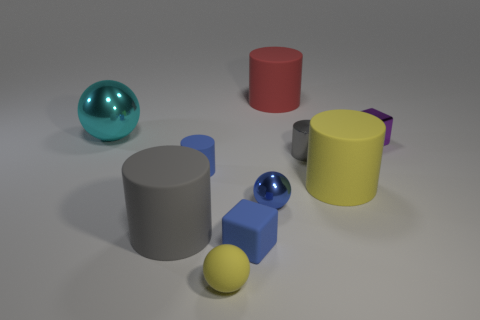Subtract all tiny balls. How many balls are left? 1 Subtract all green spheres. How many gray cylinders are left? 2 Subtract all gray cylinders. How many cylinders are left? 3 Subtract all blocks. How many objects are left? 8 Subtract 2 cylinders. How many cylinders are left? 3 Subtract 1 yellow balls. How many objects are left? 9 Subtract all purple blocks. Subtract all blue balls. How many blocks are left? 1 Subtract all yellow things. Subtract all purple matte cylinders. How many objects are left? 8 Add 7 big balls. How many big balls are left? 8 Add 2 yellow matte objects. How many yellow matte objects exist? 4 